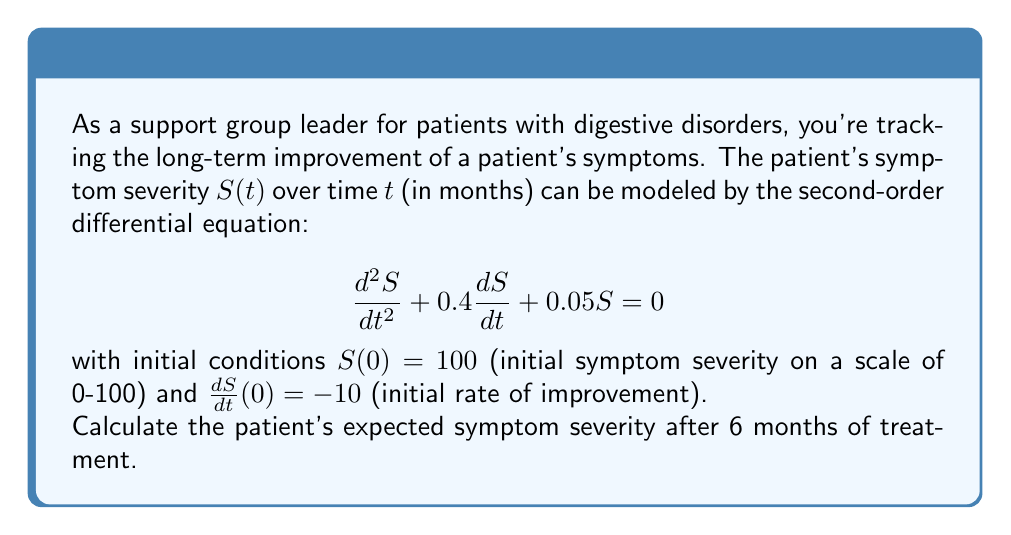Teach me how to tackle this problem. To solve this problem, we need to follow these steps:

1) The given differential equation is a second-order linear homogeneous equation with constant coefficients. Its characteristic equation is:

   $$r^2 + 0.4r + 0.05 = 0$$

2) Solving this quadratic equation:
   
   $$r = \frac{-0.4 \pm \sqrt{0.4^2 - 4(1)(0.05)}}{2(1)} = \frac{-0.4 \pm \sqrt{0.16 - 0.2}}{2} = \frac{-0.4 \pm \sqrt{-0.04}}{2}$$

3) This gives us complex roots:
   
   $$r_1 = -0.2 + 0.1i, r_2 = -0.2 - 0.1i$$

4) The general solution is therefore:

   $$S(t) = e^{-0.2t}(A\cos(0.1t) + B\sin(0.1t))$$

5) Using the initial conditions:
   
   $S(0) = 100$: This gives $A = 100$
   
   $\frac{dS}{dt}(0) = -10$: This gives $-0.2A + 0.1B = -10$, so $B = 80$

6) Our particular solution is:

   $$S(t) = e^{-0.2t}(100\cos(0.1t) + 80\sin(0.1t))$$

7) To find the symptom severity after 6 months, we calculate $S(6)$:

   $$S(6) = e^{-0.2(6)}(100\cos(0.1(6)) + 80\sin(0.1(6)))$$
   
   $$= e^{-1.2}(100\cos(0.6) + 80\sin(0.6))$$
   
   $$\approx 0.301 * (100 * 0.825 + 80 * 0.565)$$
   
   $$\approx 0.301 * (82.5 + 45.2)$$
   
   $$\approx 38.46$$

Therefore, after 6 months, the expected symptom severity is approximately 38.46 on a scale of 0-100.
Answer: 38.46 